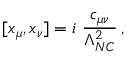<formula> <loc_0><loc_0><loc_500><loc_500>[ x _ { \mu } , x _ { \nu } ] = i \frac { c _ { \mu \nu } } { \Lambda _ { N C } ^ { 2 } } \, ,</formula> 